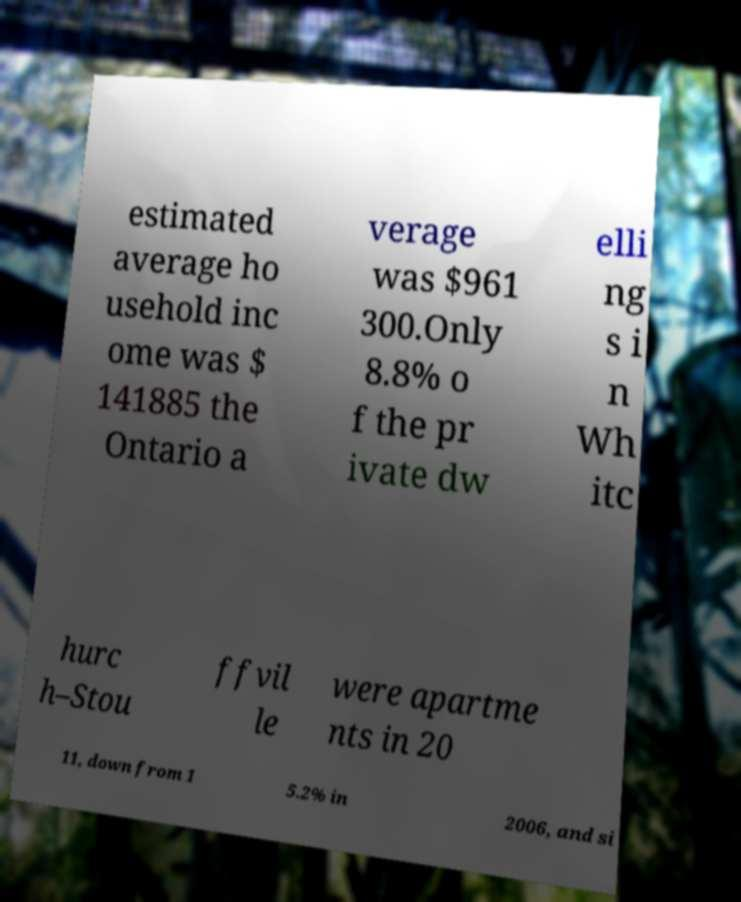Please read and relay the text visible in this image. What does it say? estimated average ho usehold inc ome was $ 141885 the Ontario a verage was $961 300.Only 8.8% o f the pr ivate dw elli ng s i n Wh itc hurc h–Stou ffvil le were apartme nts in 20 11, down from 1 5.2% in 2006, and si 